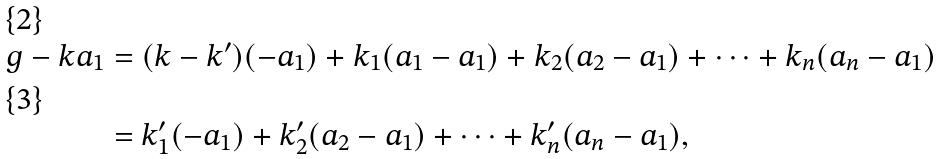Convert formula to latex. <formula><loc_0><loc_0><loc_500><loc_500>g - k a _ { 1 } & = ( k - k ^ { \prime } ) ( - a _ { 1 } ) + k _ { 1 } ( a _ { 1 } - a _ { 1 } ) + k _ { 2 } ( a _ { 2 } - a _ { 1 } ) + \dots + k _ { n } ( a _ { n } - a _ { 1 } ) \\ & = k _ { 1 } ^ { \prime } ( - a _ { 1 } ) + k _ { 2 } ^ { \prime } ( a _ { 2 } - a _ { 1 } ) + \dots + k _ { n } ^ { \prime } ( a _ { n } - a _ { 1 } ) ,</formula> 